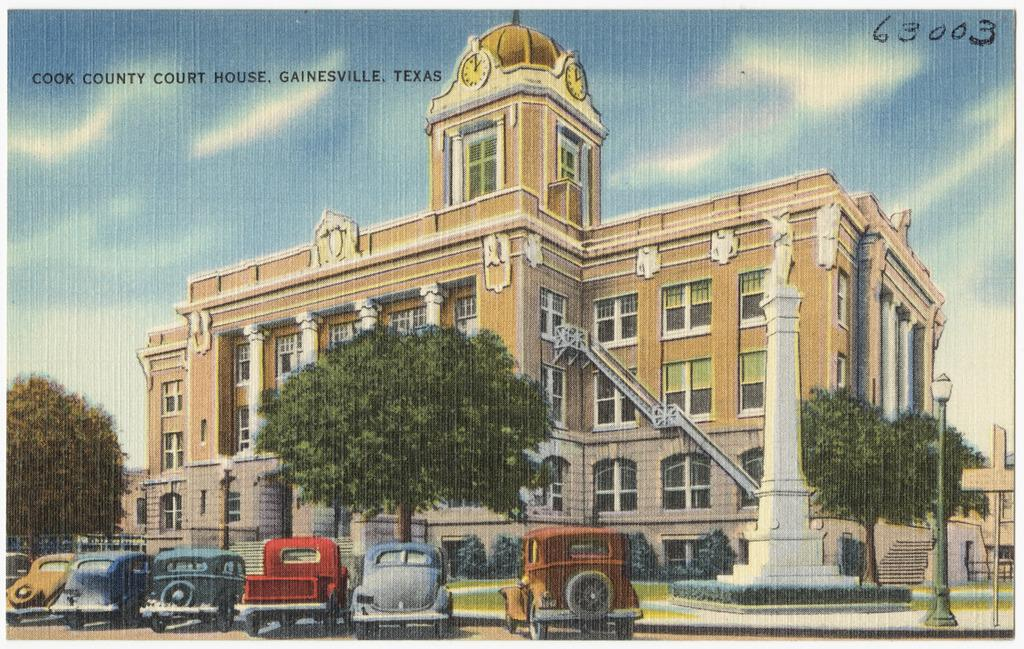What type of visual representation is the image? The image is a poster. What can be seen in the image besides the poster itself? There are vehicles, trees, plants, poles, lights, a sculpture, and a building visible in the image. What is the background of the image? The sky is visible in the background of the image. What type of grass is growing around the sculpture in the image? There is no grass visible in the image; only trees, plants, and a sculpture are present. How many oranges can be seen hanging from the trees in the image? There are no oranges present in the image; only trees and plants are visible. 